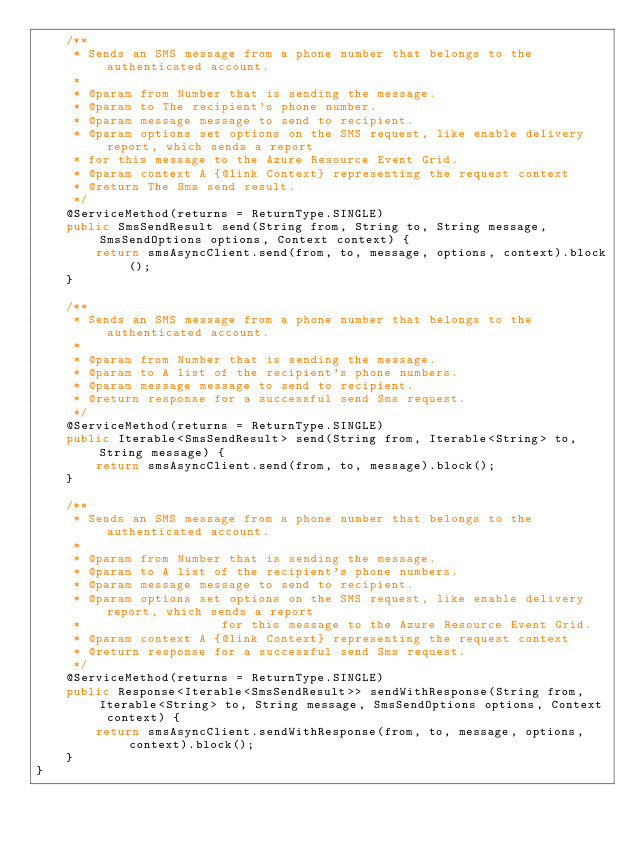<code> <loc_0><loc_0><loc_500><loc_500><_Java_>    /**
     * Sends an SMS message from a phone number that belongs to the authenticated account.
     *
     * @param from Number that is sending the message.
     * @param to The recipient's phone number.
     * @param message message to send to recipient.
     * @param options set options on the SMS request, like enable delivery report, which sends a report
     * for this message to the Azure Resource Event Grid.
     * @param context A {@link Context} representing the request context
     * @return The Sms send result.
     */
    @ServiceMethod(returns = ReturnType.SINGLE)
    public SmsSendResult send(String from, String to, String message, SmsSendOptions options, Context context) {
        return smsAsyncClient.send(from, to, message, options, context).block();
    }

    /**
     * Sends an SMS message from a phone number that belongs to the authenticated account.
     *
     * @param from Number that is sending the message.
     * @param to A list of the recipient's phone numbers.
     * @param message message to send to recipient.
     * @return response for a successful send Sms request.
     */
    @ServiceMethod(returns = ReturnType.SINGLE)
    public Iterable<SmsSendResult> send(String from, Iterable<String> to, String message) {
        return smsAsyncClient.send(from, to, message).block();
    }

    /**
     * Sends an SMS message from a phone number that belongs to the authenticated account.
     *
     * @param from Number that is sending the message.
     * @param to A list of the recipient's phone numbers.
     * @param message message to send to recipient.
     * @param options set options on the SMS request, like enable delivery report, which sends a report
     *                   for this message to the Azure Resource Event Grid.
     * @param context A {@link Context} representing the request context
     * @return response for a successful send Sms request.
     */
    @ServiceMethod(returns = ReturnType.SINGLE)
    public Response<Iterable<SmsSendResult>> sendWithResponse(String from, Iterable<String> to, String message, SmsSendOptions options, Context context) {
        return smsAsyncClient.sendWithResponse(from, to, message, options, context).block();
    }
}
</code> 